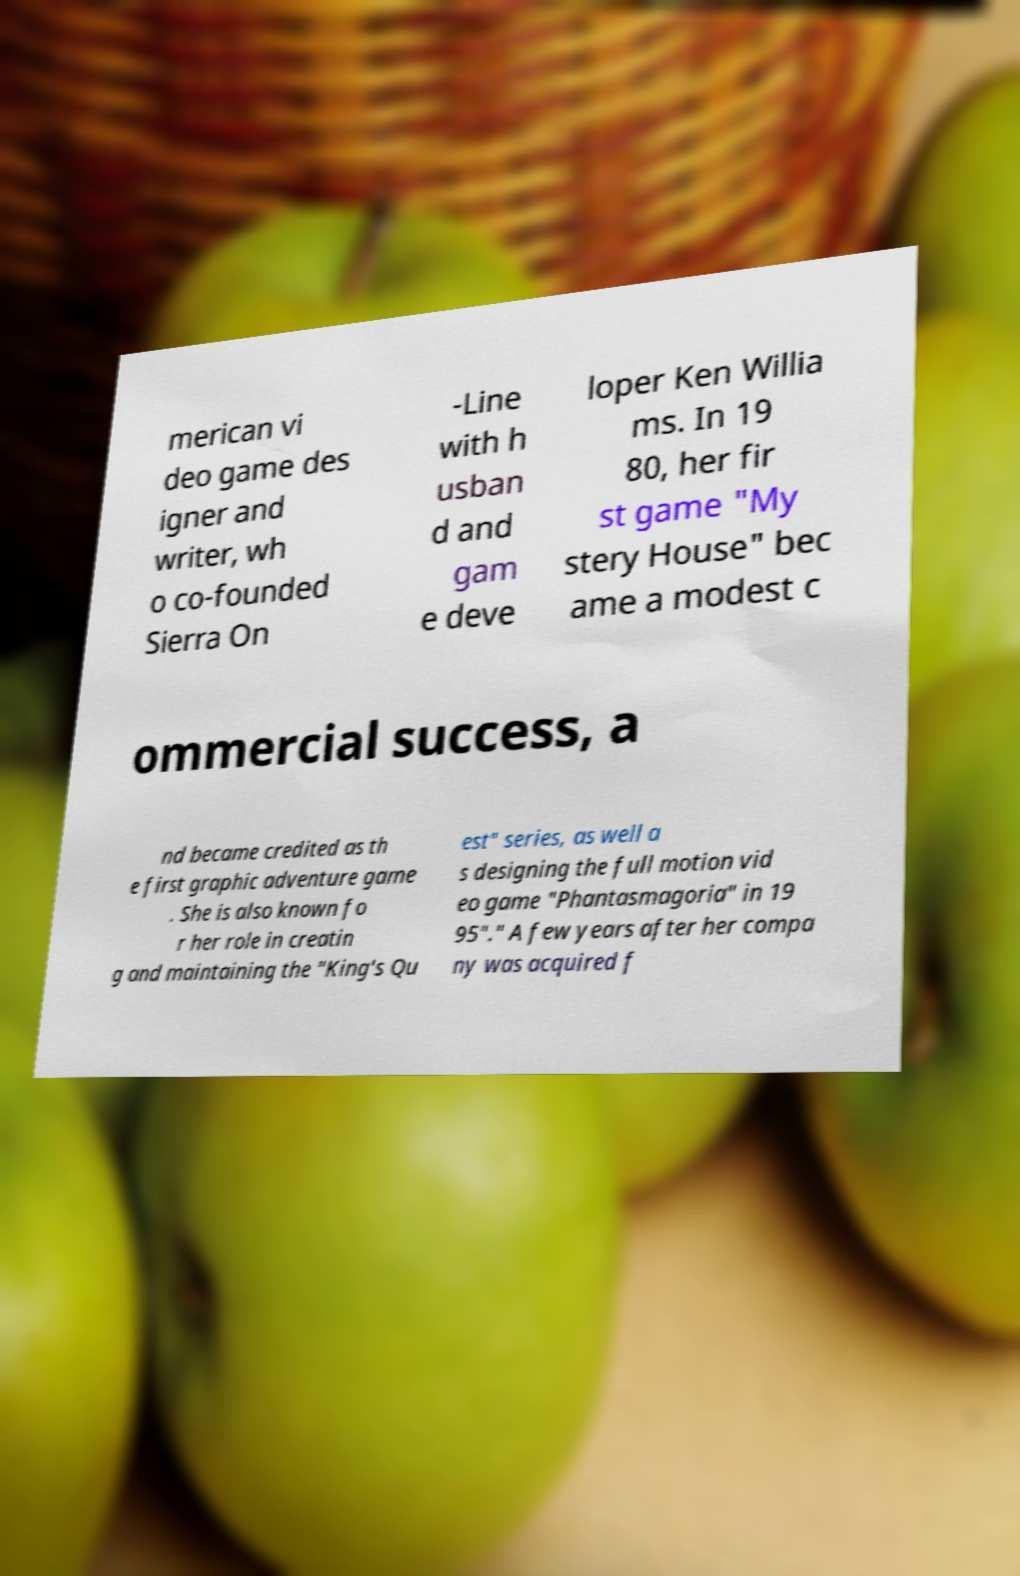I need the written content from this picture converted into text. Can you do that? merican vi deo game des igner and writer, wh o co-founded Sierra On -Line with h usban d and gam e deve loper Ken Willia ms. In 19 80, her fir st game "My stery House" bec ame a modest c ommercial success, a nd became credited as th e first graphic adventure game . She is also known fo r her role in creatin g and maintaining the "King's Qu est" series, as well a s designing the full motion vid eo game "Phantasmagoria" in 19 95"." A few years after her compa ny was acquired f 